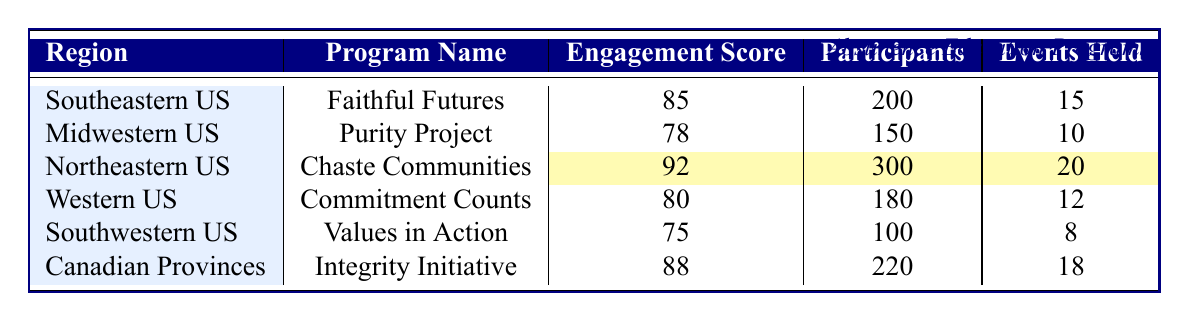What is the community engagement score of the "Purity Project"? The community engagement score of each program is listed in the table under the 'Engagement Score' column. For the "Purity Project," the score is explicitly shown as 78.
Answer: 78 Which program has the highest number of participants? To determine which program has the highest number of participants, I check the 'Participants' column in the table. "Chaste Communities" has the highest number at 300 participants.
Answer: Chaste Communities How many total events were held across all programs? I need to add up the number of events held for each program. The events held are: 15 (Faithful Futures) + 10 (Purity Project) + 20 (Chaste Communities) + 12 (Commitment Counts) + 8 (Values in Action) + 18 (Integrity Initiative) = 93 events held in total.
Answer: 93 Is the community engagement score of "Integrity Initiative" greater than the average of all scores? First, I calculate the average of the engagement scores: (85 + 78 + 92 + 80 + 75 + 88) = 498, then divide by 6 (the number of programs), which gives approximately 83. "Integrity Initiative" has a score of 88, which is greater than 83.
Answer: Yes What is the difference in community engagement scores between "Chaste Communities" and "Values in Action"? The score for "Chaste Communities" is 92, and for "Values in Action," it is 75. The difference is calculated as 92 - 75 = 17.
Answer: 17 How many more resources were distributed by the "Integrity Initiative" compared to the "Values in Action"? The resources distributed by "Integrity Initiative" is 1400 and by "Values in Action" is 500. To find the difference, I subtract: 1400 - 500 = 900.
Answer: 900 Which region has the lowest community engagement score and what is that score? Looking at the 'Engagement Score' column, "Values in Action" has the lowest score of 75 among the listed programs.
Answer: 75 If we combine the number of participants from the "Faithful Futures" and "Integrity Initiative," what is the total? The number of participants for "Faithful Futures" is 200 and for "Integrity Initiative" is 220. Adding these together gives 200 + 220 = 420 participants.
Answer: 420 Does "Commitment Counts" have more events held than "Purity Project"? "Commitment Counts" has held 12 events while "Purity Project" has held 10. Since 12 is greater than 10, the statement is true.
Answer: Yes In which region was the "Chaste Communities" program implemented? The 'Region' column indicates the region for each program. "Chaste Communities" is implemented in the Northeastern United States.
Answer: Northeastern United States 